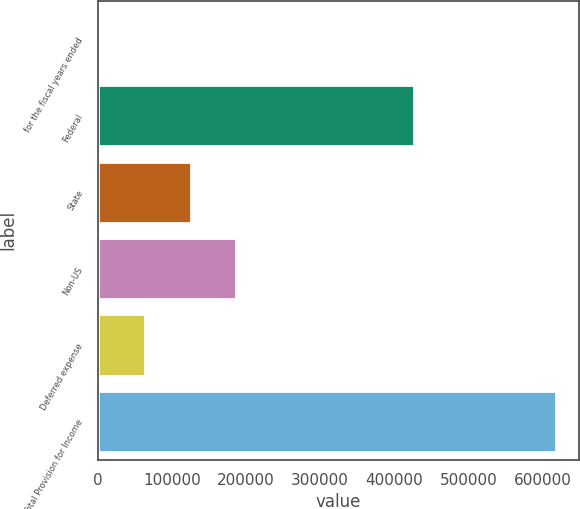Convert chart to OTSL. <chart><loc_0><loc_0><loc_500><loc_500><bar_chart><fcel>for the fiscal years ended<fcel>Federal<fcel>State<fcel>Non-US<fcel>Deferred expense<fcel>Total Provision for Income<nl><fcel>2010<fcel>426470<fcel>125270<fcel>186901<fcel>63640.2<fcel>618312<nl></chart> 